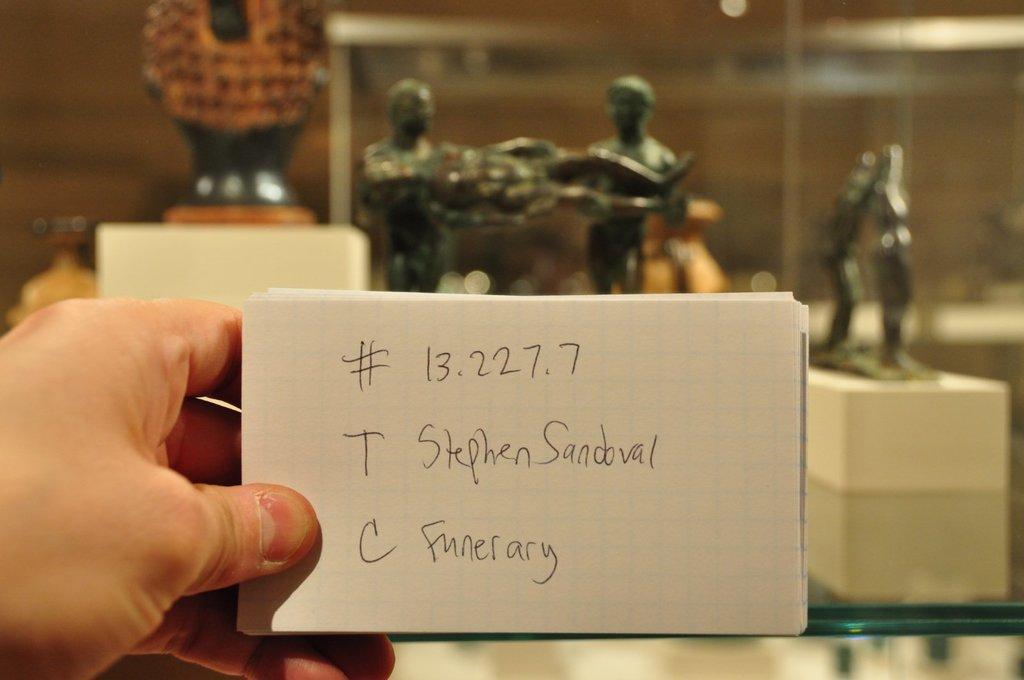Describe this image in one or two sentences. In this image there is a person holding the papers with the hand. On the papers there is some text. In the background there are statues. 